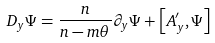Convert formula to latex. <formula><loc_0><loc_0><loc_500><loc_500>D _ { y } \Psi = \frac { n } { n - m \theta } \partial _ { y } \Psi + \left [ A ^ { \prime } _ { y } , \Psi \right ]</formula> 